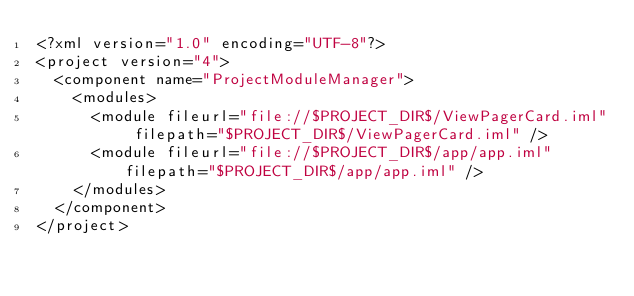<code> <loc_0><loc_0><loc_500><loc_500><_XML_><?xml version="1.0" encoding="UTF-8"?>
<project version="4">
  <component name="ProjectModuleManager">
    <modules>
      <module fileurl="file://$PROJECT_DIR$/ViewPagerCard.iml" filepath="$PROJECT_DIR$/ViewPagerCard.iml" />
      <module fileurl="file://$PROJECT_DIR$/app/app.iml" filepath="$PROJECT_DIR$/app/app.iml" />
    </modules>
  </component>
</project></code> 